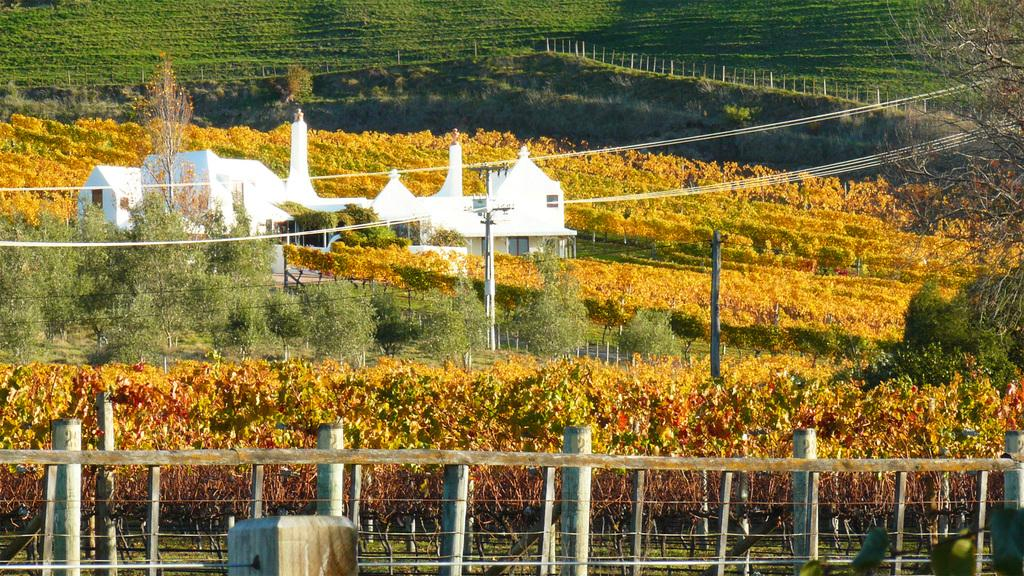What is the setting of the image? The image is an outside view. What is located at the bottom of the image? There is a fencing at the bottom of the image. What is the main structure in the middle of the image? There is a building in the middle of the image. What can be seen in the background of the image? There are many trees and few poles in the background of the image. What type of bit is being used by the horse in the image? There is no horse or bit present in the image. What holiday is being celebrated in the image? There is no indication of a holiday being celebrated in the image. 